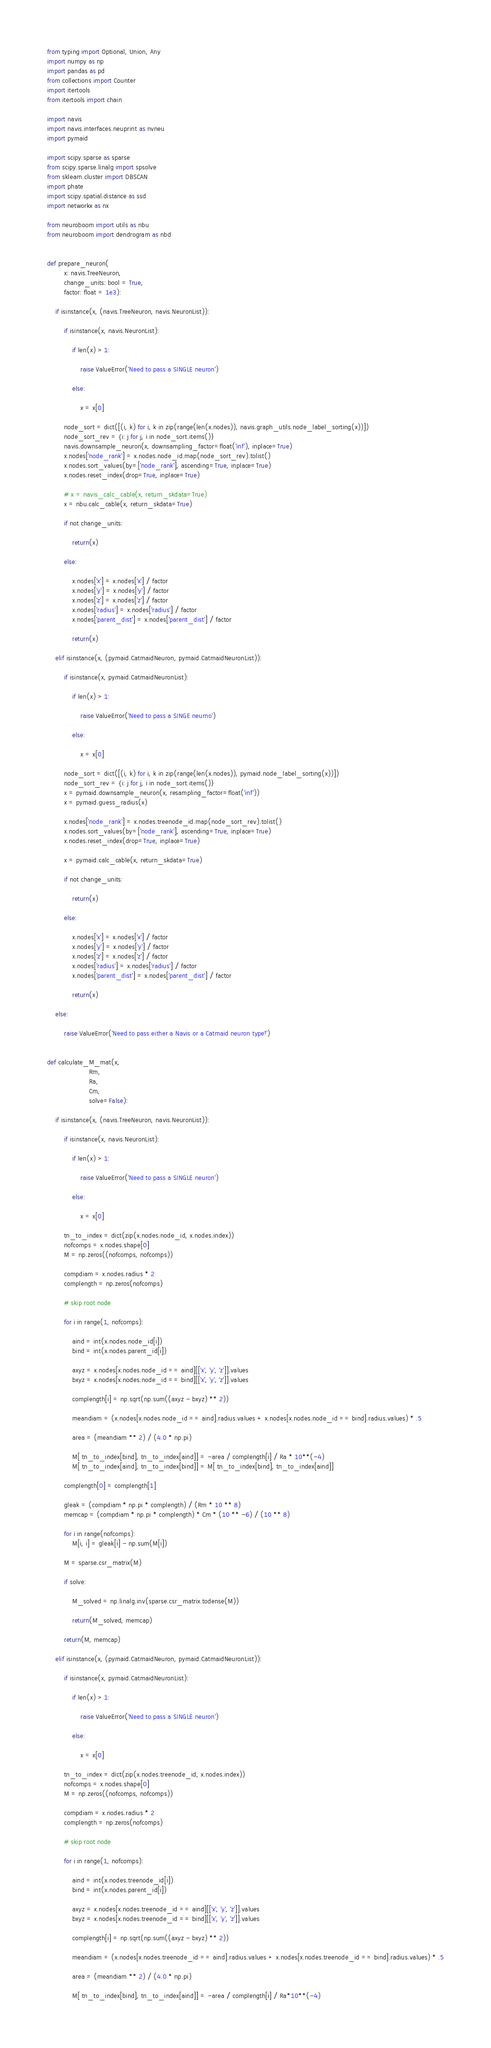Convert code to text. <code><loc_0><loc_0><loc_500><loc_500><_Python_>from typing import Optional, Union, Any
import numpy as np
import pandas as pd
from collections import Counter
import itertools
from itertools import chain

import navis
import navis.interfaces.neuprint as nvneu
import pymaid

import scipy.sparse as sparse
from scipy.sparse.linalg import spsolve
from sklearn.cluster import DBSCAN
import phate
import scipy.spatial.distance as ssd
import networkx as nx

from neuroboom import utils as nbu
from neuroboom import dendrogram as nbd


def prepare_neuron(
        x: navis.TreeNeuron,
        change_units: bool = True,
        factor: float = 1e3):

    if isinstance(x, (navis.TreeNeuron, navis.NeuronList)):

        if isinstance(x, navis.NeuronList):

            if len(x) > 1:

                raise ValueError('Need to pass a SINGLE neuron')

            else:

                x = x[0]

        node_sort = dict([(i, k) for i, k in zip(range(len(x.nodes)), navis.graph_utils.node_label_sorting(x))])
        node_sort_rev = {i: j for j, i in node_sort.items()}
        navis.downsample_neuron(x, downsampling_factor=float('inf'), inplace=True)
        x.nodes['node_rank'] = x.nodes.node_id.map(node_sort_rev).tolist()
        x.nodes.sort_values(by=['node_rank'], ascending=True, inplace=True)
        x.nodes.reset_index(drop=True, inplace=True)

        # x = navis_calc_cable(x, return_skdata=True)
        x = nbu.calc_cable(x, return_skdata=True)

        if not change_units:

            return(x)

        else:

            x.nodes['x'] = x.nodes['x'] / factor
            x.nodes['y'] = x.nodes['y'] / factor
            x.nodes['z'] = x.nodes['z'] / factor
            x.nodes['radius'] = x.nodes['radius'] / factor
            x.nodes['parent_dist'] = x.nodes['parent_dist'] / factor

            return(x)

    elif isinstance(x, (pymaid.CatmaidNeuron, pymaid.CatmaidNeuronList)):

        if isinstance(x, pymaid.CatmaidNeuronList):

            if len(x) > 1:

                raise ValueError('Need to pass a SINGE neurno')

            else:

                x = x[0]

        node_sort = dict([(i, k) for i, k in zip(range(len(x.nodes)), pymaid.node_label_sorting(x))])
        node_sort_rev = {i: j for j, i in node_sort.items()}
        x = pymaid.downsample_neuron(x, resampling_factor=float('inf'))
        x = pymaid.guess_radius(x)

        x.nodes['node_rank'] = x.nodes.treenode_id.map(node_sort_rev).tolist()
        x.nodes.sort_values(by=['node_rank'], ascending=True, inplace=True)
        x.nodes.reset_index(drop=True, inplace=True)

        x = pymaid.calc_cable(x, return_skdata=True)

        if not change_units:

            return(x)

        else:

            x.nodes['x'] = x.nodes['x'] / factor
            x.nodes['y'] = x.nodes['y'] / factor
            x.nodes['z'] = x.nodes['z'] / factor
            x.nodes['radius'] = x.nodes['radius'] / factor
            x.nodes['parent_dist'] = x.nodes['parent_dist'] / factor

            return(x)

    else:

        raise ValueError('Need to pass either a Navis or a Catmaid neuron type!')


def calculate_M_mat(x,
                    Rm,
                    Ra,
                    Cm,
                    solve=False):

    if isinstance(x, (navis.TreeNeuron, navis.NeuronList)):

        if isinstance(x, navis.NeuronList):

            if len(x) > 1:

                raise ValueError('Need to pass a SINGLE neuron')

            else:

                x = x[0]

        tn_to_index = dict(zip(x.nodes.node_id, x.nodes.index))
        nofcomps = x.nodes.shape[0]
        M = np.zeros((nofcomps, nofcomps))

        compdiam = x.nodes.radius * 2
        complength = np.zeros(nofcomps)

        # skip root node

        for i in range(1, nofcomps):

            aind = int(x.nodes.node_id[i])
            bind = int(x.nodes.parent_id[i])

            axyz = x.nodes[x.nodes.node_id == aind][['x', 'y', 'z']].values
            bxyz = x.nodes[x.nodes.node_id == bind][['x', 'y', 'z']].values

            complength[i] = np.sqrt(np.sum((axyz - bxyz) ** 2))

            meandiam = (x.nodes[x.nodes.node_id == aind].radius.values + x.nodes[x.nodes.node_id == bind].radius.values) * .5

            area = (meandiam ** 2) / (4.0 * np.pi)

            M[ tn_to_index[bind], tn_to_index[aind]] = -area / complength[i] / Ra * 10**(-4)
            M[ tn_to_index[aind], tn_to_index[bind]] = M[ tn_to_index[bind], tn_to_index[aind]]

        complength[0] = complength[1]

        gleak = (compdiam * np.pi * complength) / (Rm * 10 ** 8)
        memcap = (compdiam * np.pi * complength) * Cm * (10 ** -6) / (10 ** 8)

        for i in range(nofcomps):
            M[i, i] = gleak[i] - np.sum(M[i])

        M = sparse.csr_matrix(M)

        if solve:

            M_solved = np.linalg.inv(sparse.csr_matrix.todense(M))

            return(M_solved, memcap)

        return(M, memcap)

    elif isinstance(x, (pymaid.CatmaidNeuron, pymaid.CatmaidNeuronList)):

        if isinstance(x, pymaid.CatmaidNeuronList):

            if len(x) > 1:

                raise ValueError('Need to pass a SINGLE neuron')

            else:

                x = x[0]

        tn_to_index = dict(zip(x.nodes.treenode_id, x.nodes.index))
        nofcomps = x.nodes.shape[0]
        M = np.zeros((nofcomps, nofcomps))

        compdiam = x.nodes.radius * 2
        complength = np.zeros(nofcomps)

        # skip root node

        for i in range(1, nofcomps):

            aind = int(x.nodes.treenode_id[i])
            bind = int(x.nodes.parent_id[i])

            axyz = x.nodes[x.nodes.treenode_id == aind][['x', 'y', 'z']].values
            bxyz = x.nodes[x.nodes.treenode_id == bind][['x', 'y', 'z']].values

            complength[i] = np.sqrt(np.sum((axyz - bxyz) ** 2))

            meandiam = (x.nodes[x.nodes.treenode_id == aind].radius.values + x.nodes[x.nodes.treenode_id == bind].radius.values) * .5

            area = (meandiam ** 2) / (4.0 * np.pi)

            M[ tn_to_index[bind], tn_to_index[aind]] = -area / complength[i] / Ra*10**(-4)</code> 